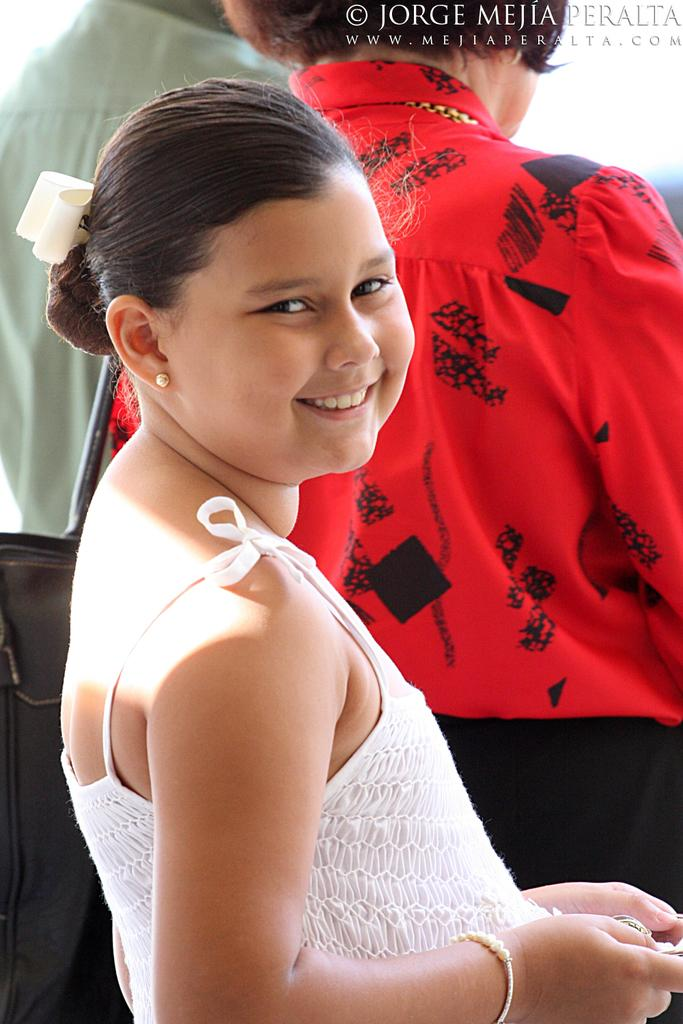Who is the main subject in the image? There is a girl in the image. What is the girl doing in the image? The girl is smiling. Are there any other people visible in the image? Yes, there are two persons standing in the background of the image. Can you describe any additional features of the image? There is a watermark on the image. What type of stone can be seen in the girl's hand in the image? There is no stone present in the girl's hand or in the image. What sound can be heard coming from the girl in the image? There is no sound present in the image, as it is a still photograph. 